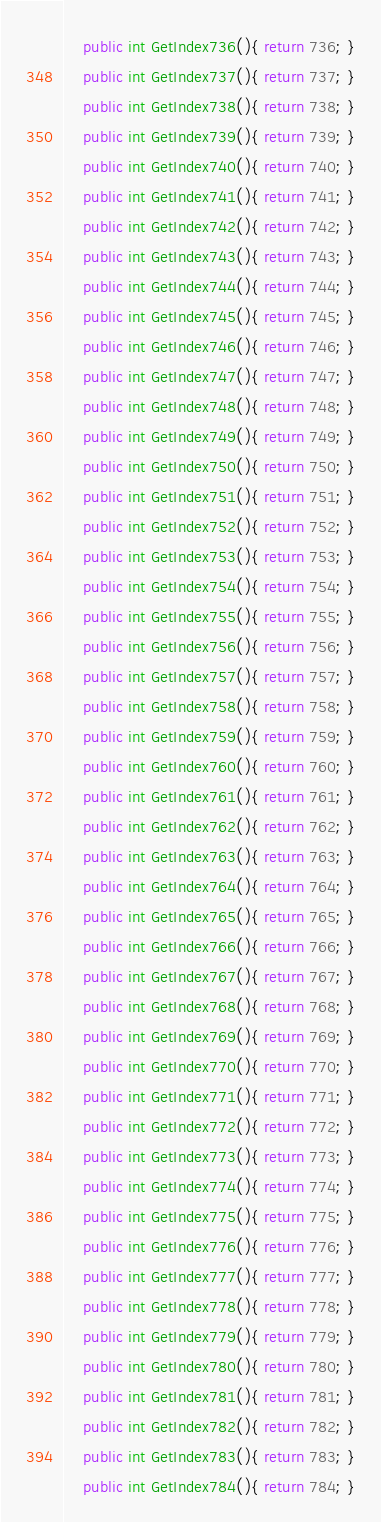Convert code to text. <code><loc_0><loc_0><loc_500><loc_500><_C#_>	public int GetIndex736(){ return 736; }
	public int GetIndex737(){ return 737; }
	public int GetIndex738(){ return 738; }
	public int GetIndex739(){ return 739; }
	public int GetIndex740(){ return 740; }
	public int GetIndex741(){ return 741; }
	public int GetIndex742(){ return 742; }
	public int GetIndex743(){ return 743; }
	public int GetIndex744(){ return 744; }
	public int GetIndex745(){ return 745; }
	public int GetIndex746(){ return 746; }
	public int GetIndex747(){ return 747; }
	public int GetIndex748(){ return 748; }
	public int GetIndex749(){ return 749; }
	public int GetIndex750(){ return 750; }
	public int GetIndex751(){ return 751; }
	public int GetIndex752(){ return 752; }
	public int GetIndex753(){ return 753; }
	public int GetIndex754(){ return 754; }
	public int GetIndex755(){ return 755; }
	public int GetIndex756(){ return 756; }
	public int GetIndex757(){ return 757; }
	public int GetIndex758(){ return 758; }
	public int GetIndex759(){ return 759; }
	public int GetIndex760(){ return 760; }
	public int GetIndex761(){ return 761; }
	public int GetIndex762(){ return 762; }
	public int GetIndex763(){ return 763; }
	public int GetIndex764(){ return 764; }
	public int GetIndex765(){ return 765; }
	public int GetIndex766(){ return 766; }
	public int GetIndex767(){ return 767; }
	public int GetIndex768(){ return 768; }
	public int GetIndex769(){ return 769; }
	public int GetIndex770(){ return 770; }
	public int GetIndex771(){ return 771; }
	public int GetIndex772(){ return 772; }
	public int GetIndex773(){ return 773; }
	public int GetIndex774(){ return 774; }
	public int GetIndex775(){ return 775; }
	public int GetIndex776(){ return 776; }
	public int GetIndex777(){ return 777; }
	public int GetIndex778(){ return 778; }
	public int GetIndex779(){ return 779; }
	public int GetIndex780(){ return 780; }
	public int GetIndex781(){ return 781; }
	public int GetIndex782(){ return 782; }
	public int GetIndex783(){ return 783; }
	public int GetIndex784(){ return 784; }</code> 